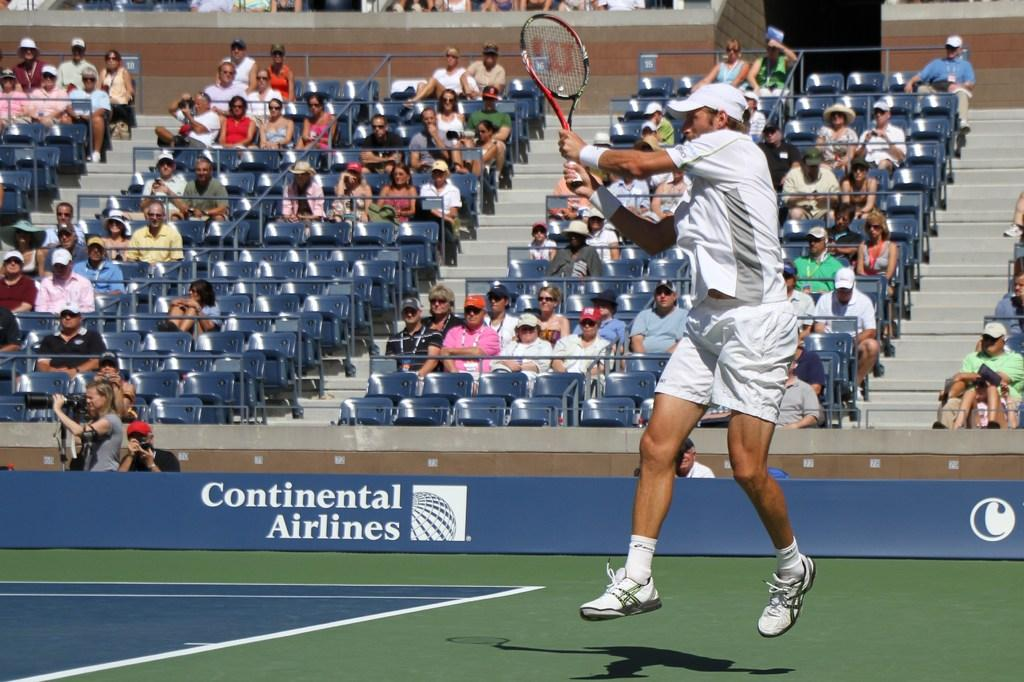What is the man in the image holding? The man is holding a racket in the image. What are the people in the image doing? The people are sitting on chairs in the image. What type of surface is visible in the image? There is a ground in the image. What object can be seen in addition to the chairs and ground? There is a board in the image. Can you see any fish swimming on the sidewalk in the image? There is no sidewalk or fish present in the image. 